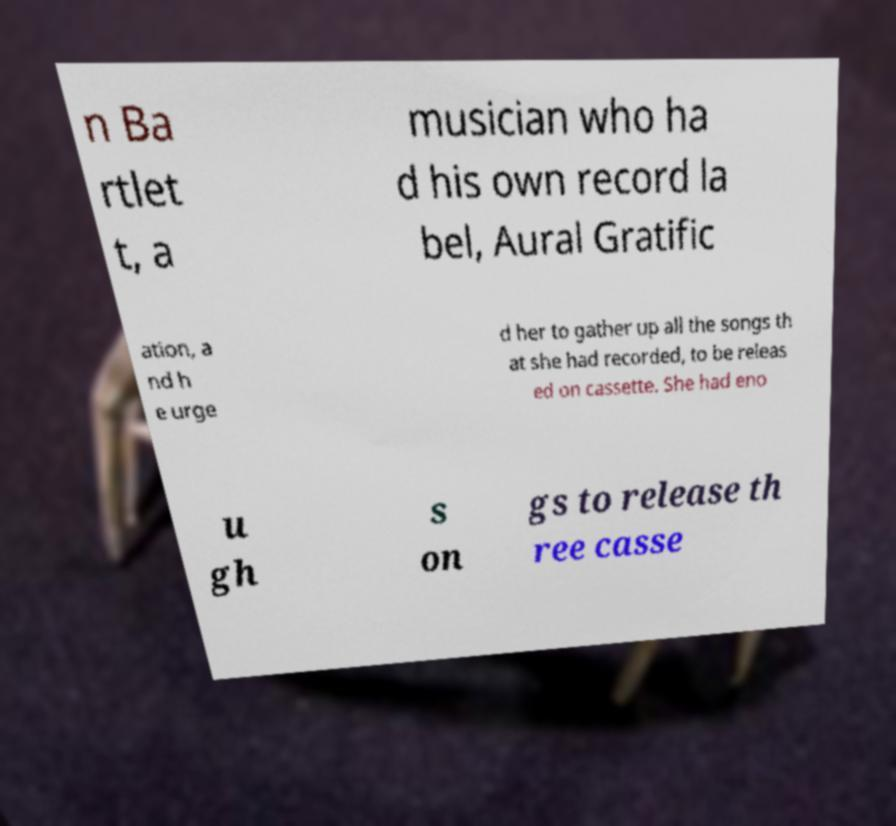Please identify and transcribe the text found in this image. n Ba rtlet t, a musician who ha d his own record la bel, Aural Gratific ation, a nd h e urge d her to gather up all the songs th at she had recorded, to be releas ed on cassette. She had eno u gh s on gs to release th ree casse 